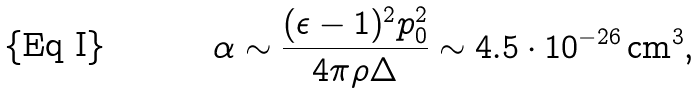Convert formula to latex. <formula><loc_0><loc_0><loc_500><loc_500>\alpha \sim \frac { ( \epsilon - 1 ) ^ { 2 } p _ { 0 } ^ { 2 } } { 4 \pi \rho \Delta } \sim 4 . 5 \cdot 1 0 ^ { - 2 6 } \, \text {cm} ^ { 3 } ,</formula> 